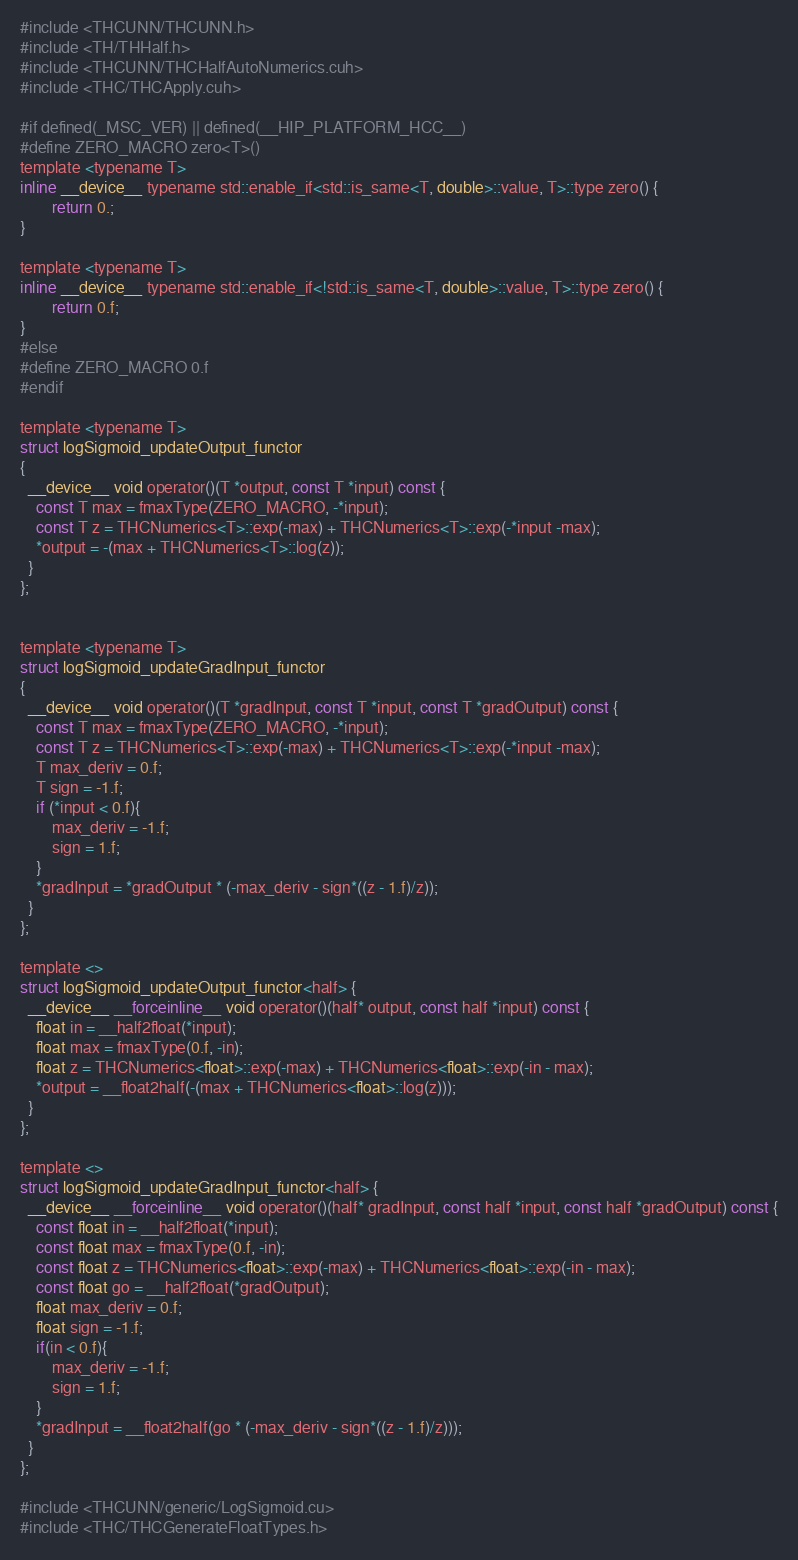Convert code to text. <code><loc_0><loc_0><loc_500><loc_500><_Cuda_>#include <THCUNN/THCUNN.h>
#include <TH/THHalf.h>
#include <THCUNN/THCHalfAutoNumerics.cuh>
#include <THC/THCApply.cuh>

#if defined(_MSC_VER) || defined(__HIP_PLATFORM_HCC__)
#define ZERO_MACRO zero<T>()
template <typename T>
inline __device__ typename std::enable_if<std::is_same<T, double>::value, T>::type zero() {
        return 0.;
}

template <typename T>
inline __device__ typename std::enable_if<!std::is_same<T, double>::value, T>::type zero() {
        return 0.f;
}
#else
#define ZERO_MACRO 0.f
#endif

template <typename T>
struct logSigmoid_updateOutput_functor
{
  __device__ void operator()(T *output, const T *input) const {
    const T max = fmaxType(ZERO_MACRO, -*input);
    const T z = THCNumerics<T>::exp(-max) + THCNumerics<T>::exp(-*input -max);
    *output = -(max + THCNumerics<T>::log(z));
  }
};


template <typename T>
struct logSigmoid_updateGradInput_functor
{
  __device__ void operator()(T *gradInput, const T *input, const T *gradOutput) const {
    const T max = fmaxType(ZERO_MACRO, -*input);
    const T z = THCNumerics<T>::exp(-max) + THCNumerics<T>::exp(-*input -max);
    T max_deriv = 0.f;
    T sign = -1.f;
    if (*input < 0.f){
        max_deriv = -1.f;
        sign = 1.f;
    }
    *gradInput = *gradOutput * (-max_deriv - sign*((z - 1.f)/z));
  }
};

template <>
struct logSigmoid_updateOutput_functor<half> {
  __device__ __forceinline__ void operator()(half* output, const half *input) const {
    float in = __half2float(*input);
    float max = fmaxType(0.f, -in);
    float z = THCNumerics<float>::exp(-max) + THCNumerics<float>::exp(-in - max);
    *output = __float2half(-(max + THCNumerics<float>::log(z)));
  }
};

template <>
struct logSigmoid_updateGradInput_functor<half> {
  __device__ __forceinline__ void operator()(half* gradInput, const half *input, const half *gradOutput) const {
    const float in = __half2float(*input);
    const float max = fmaxType(0.f, -in);
    const float z = THCNumerics<float>::exp(-max) + THCNumerics<float>::exp(-in - max);
    const float go = __half2float(*gradOutput);
    float max_deriv = 0.f;
    float sign = -1.f;
    if(in < 0.f){
        max_deriv = -1.f;
        sign = 1.f;
    }
    *gradInput = __float2half(go * (-max_deriv - sign*((z - 1.f)/z)));
  }
};

#include <THCUNN/generic/LogSigmoid.cu>
#include <THC/THCGenerateFloatTypes.h>
</code> 